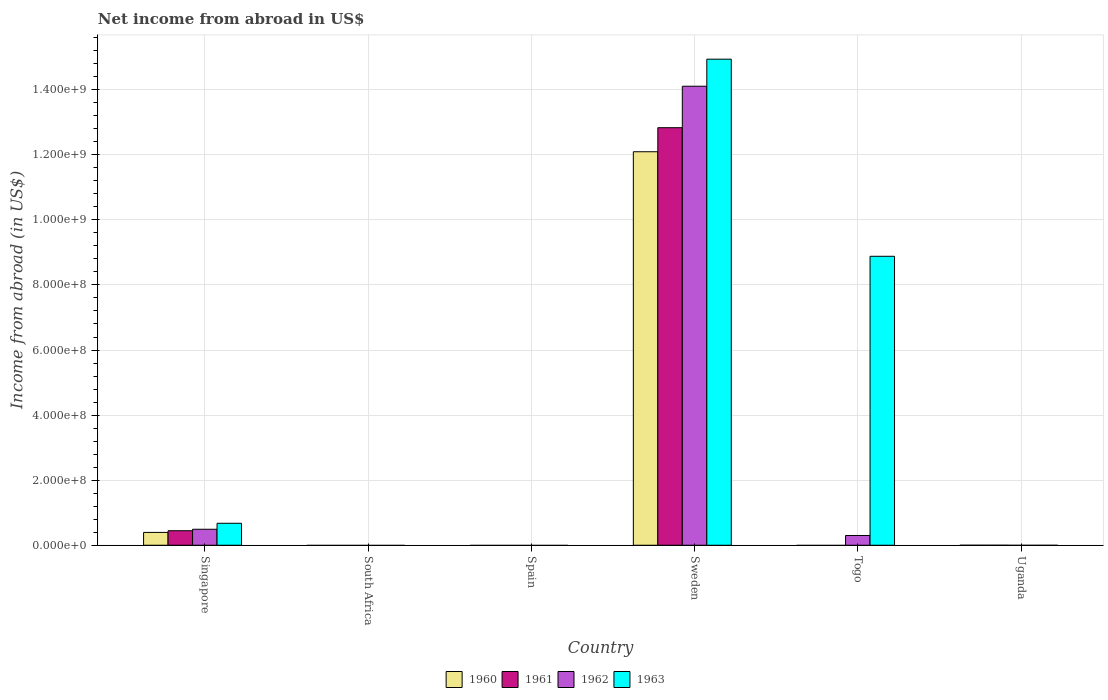Are the number of bars per tick equal to the number of legend labels?
Provide a short and direct response. No. Are the number of bars on each tick of the X-axis equal?
Give a very brief answer. No. How many bars are there on the 6th tick from the left?
Provide a succinct answer. 0. What is the label of the 5th group of bars from the left?
Provide a succinct answer. Togo. In how many cases, is the number of bars for a given country not equal to the number of legend labels?
Provide a succinct answer. 4. What is the net income from abroad in 1962 in South Africa?
Provide a short and direct response. 0. Across all countries, what is the maximum net income from abroad in 1963?
Your response must be concise. 1.49e+09. What is the total net income from abroad in 1960 in the graph?
Your response must be concise. 1.25e+09. What is the average net income from abroad in 1960 per country?
Your response must be concise. 2.08e+08. What is the difference between the net income from abroad of/in 1963 and net income from abroad of/in 1962 in Singapore?
Provide a short and direct response. 1.84e+07. In how many countries, is the net income from abroad in 1961 greater than 1160000000 US$?
Your answer should be compact. 1. What is the ratio of the net income from abroad in 1962 in Singapore to that in Togo?
Make the answer very short. 1.64. What is the difference between the highest and the second highest net income from abroad in 1962?
Offer a very short reply. 1.38e+09. What is the difference between the highest and the lowest net income from abroad in 1961?
Ensure brevity in your answer.  1.28e+09. In how many countries, is the net income from abroad in 1962 greater than the average net income from abroad in 1962 taken over all countries?
Provide a succinct answer. 1. Is it the case that in every country, the sum of the net income from abroad in 1962 and net income from abroad in 1963 is greater than the sum of net income from abroad in 1961 and net income from abroad in 1960?
Offer a very short reply. No. Is it the case that in every country, the sum of the net income from abroad in 1962 and net income from abroad in 1963 is greater than the net income from abroad in 1961?
Offer a very short reply. No. How many bars are there?
Keep it short and to the point. 10. What is the difference between two consecutive major ticks on the Y-axis?
Offer a very short reply. 2.00e+08. Where does the legend appear in the graph?
Ensure brevity in your answer.  Bottom center. How many legend labels are there?
Provide a succinct answer. 4. What is the title of the graph?
Ensure brevity in your answer.  Net income from abroad in US$. What is the label or title of the X-axis?
Provide a short and direct response. Country. What is the label or title of the Y-axis?
Make the answer very short. Income from abroad (in US$). What is the Income from abroad (in US$) in 1960 in Singapore?
Offer a very short reply. 3.94e+07. What is the Income from abroad (in US$) in 1961 in Singapore?
Provide a succinct answer. 4.46e+07. What is the Income from abroad (in US$) of 1962 in Singapore?
Offer a terse response. 4.91e+07. What is the Income from abroad (in US$) in 1963 in Singapore?
Keep it short and to the point. 6.75e+07. What is the Income from abroad (in US$) of 1961 in South Africa?
Keep it short and to the point. 0. What is the Income from abroad (in US$) in 1962 in South Africa?
Offer a terse response. 0. What is the Income from abroad (in US$) of 1961 in Spain?
Offer a very short reply. 0. What is the Income from abroad (in US$) of 1962 in Spain?
Make the answer very short. 0. What is the Income from abroad (in US$) in 1963 in Spain?
Make the answer very short. 0. What is the Income from abroad (in US$) in 1960 in Sweden?
Offer a terse response. 1.21e+09. What is the Income from abroad (in US$) of 1961 in Sweden?
Make the answer very short. 1.28e+09. What is the Income from abroad (in US$) of 1962 in Sweden?
Offer a terse response. 1.41e+09. What is the Income from abroad (in US$) in 1963 in Sweden?
Make the answer very short. 1.49e+09. What is the Income from abroad (in US$) of 1960 in Togo?
Your response must be concise. 0. What is the Income from abroad (in US$) of 1961 in Togo?
Offer a terse response. 0. What is the Income from abroad (in US$) of 1962 in Togo?
Offer a very short reply. 3.00e+07. What is the Income from abroad (in US$) of 1963 in Togo?
Give a very brief answer. 8.88e+08. What is the Income from abroad (in US$) in 1960 in Uganda?
Provide a succinct answer. 0. Across all countries, what is the maximum Income from abroad (in US$) of 1960?
Offer a very short reply. 1.21e+09. Across all countries, what is the maximum Income from abroad (in US$) of 1961?
Your response must be concise. 1.28e+09. Across all countries, what is the maximum Income from abroad (in US$) of 1962?
Make the answer very short. 1.41e+09. Across all countries, what is the maximum Income from abroad (in US$) in 1963?
Your answer should be compact. 1.49e+09. What is the total Income from abroad (in US$) in 1960 in the graph?
Make the answer very short. 1.25e+09. What is the total Income from abroad (in US$) in 1961 in the graph?
Offer a terse response. 1.33e+09. What is the total Income from abroad (in US$) in 1962 in the graph?
Provide a short and direct response. 1.49e+09. What is the total Income from abroad (in US$) in 1963 in the graph?
Your response must be concise. 2.45e+09. What is the difference between the Income from abroad (in US$) in 1960 in Singapore and that in Sweden?
Provide a succinct answer. -1.17e+09. What is the difference between the Income from abroad (in US$) in 1961 in Singapore and that in Sweden?
Your answer should be very brief. -1.24e+09. What is the difference between the Income from abroad (in US$) of 1962 in Singapore and that in Sweden?
Your answer should be compact. -1.36e+09. What is the difference between the Income from abroad (in US$) in 1963 in Singapore and that in Sweden?
Give a very brief answer. -1.43e+09. What is the difference between the Income from abroad (in US$) in 1962 in Singapore and that in Togo?
Give a very brief answer. 1.92e+07. What is the difference between the Income from abroad (in US$) in 1963 in Singapore and that in Togo?
Offer a very short reply. -8.21e+08. What is the difference between the Income from abroad (in US$) in 1962 in Sweden and that in Togo?
Give a very brief answer. 1.38e+09. What is the difference between the Income from abroad (in US$) in 1963 in Sweden and that in Togo?
Provide a succinct answer. 6.06e+08. What is the difference between the Income from abroad (in US$) of 1960 in Singapore and the Income from abroad (in US$) of 1961 in Sweden?
Ensure brevity in your answer.  -1.24e+09. What is the difference between the Income from abroad (in US$) in 1960 in Singapore and the Income from abroad (in US$) in 1962 in Sweden?
Your response must be concise. -1.37e+09. What is the difference between the Income from abroad (in US$) in 1960 in Singapore and the Income from abroad (in US$) in 1963 in Sweden?
Your answer should be very brief. -1.45e+09. What is the difference between the Income from abroad (in US$) of 1961 in Singapore and the Income from abroad (in US$) of 1962 in Sweden?
Give a very brief answer. -1.37e+09. What is the difference between the Income from abroad (in US$) in 1961 in Singapore and the Income from abroad (in US$) in 1963 in Sweden?
Your answer should be very brief. -1.45e+09. What is the difference between the Income from abroad (in US$) in 1962 in Singapore and the Income from abroad (in US$) in 1963 in Sweden?
Ensure brevity in your answer.  -1.44e+09. What is the difference between the Income from abroad (in US$) in 1960 in Singapore and the Income from abroad (in US$) in 1962 in Togo?
Your response must be concise. 9.45e+06. What is the difference between the Income from abroad (in US$) in 1960 in Singapore and the Income from abroad (in US$) in 1963 in Togo?
Provide a succinct answer. -8.49e+08. What is the difference between the Income from abroad (in US$) of 1961 in Singapore and the Income from abroad (in US$) of 1962 in Togo?
Your answer should be very brief. 1.46e+07. What is the difference between the Income from abroad (in US$) of 1961 in Singapore and the Income from abroad (in US$) of 1963 in Togo?
Make the answer very short. -8.44e+08. What is the difference between the Income from abroad (in US$) of 1962 in Singapore and the Income from abroad (in US$) of 1963 in Togo?
Your answer should be very brief. -8.39e+08. What is the difference between the Income from abroad (in US$) in 1960 in Sweden and the Income from abroad (in US$) in 1962 in Togo?
Offer a very short reply. 1.18e+09. What is the difference between the Income from abroad (in US$) of 1960 in Sweden and the Income from abroad (in US$) of 1963 in Togo?
Your answer should be very brief. 3.21e+08. What is the difference between the Income from abroad (in US$) in 1961 in Sweden and the Income from abroad (in US$) in 1962 in Togo?
Ensure brevity in your answer.  1.25e+09. What is the difference between the Income from abroad (in US$) of 1961 in Sweden and the Income from abroad (in US$) of 1963 in Togo?
Provide a short and direct response. 3.95e+08. What is the difference between the Income from abroad (in US$) in 1962 in Sweden and the Income from abroad (in US$) in 1963 in Togo?
Offer a very short reply. 5.23e+08. What is the average Income from abroad (in US$) in 1960 per country?
Offer a very short reply. 2.08e+08. What is the average Income from abroad (in US$) in 1961 per country?
Your answer should be compact. 2.21e+08. What is the average Income from abroad (in US$) in 1962 per country?
Your answer should be compact. 2.48e+08. What is the average Income from abroad (in US$) in 1963 per country?
Provide a short and direct response. 4.08e+08. What is the difference between the Income from abroad (in US$) in 1960 and Income from abroad (in US$) in 1961 in Singapore?
Your response must be concise. -5.20e+06. What is the difference between the Income from abroad (in US$) of 1960 and Income from abroad (in US$) of 1962 in Singapore?
Your answer should be compact. -9.70e+06. What is the difference between the Income from abroad (in US$) in 1960 and Income from abroad (in US$) in 1963 in Singapore?
Provide a succinct answer. -2.81e+07. What is the difference between the Income from abroad (in US$) in 1961 and Income from abroad (in US$) in 1962 in Singapore?
Give a very brief answer. -4.50e+06. What is the difference between the Income from abroad (in US$) of 1961 and Income from abroad (in US$) of 1963 in Singapore?
Your answer should be compact. -2.29e+07. What is the difference between the Income from abroad (in US$) in 1962 and Income from abroad (in US$) in 1963 in Singapore?
Your answer should be compact. -1.84e+07. What is the difference between the Income from abroad (in US$) of 1960 and Income from abroad (in US$) of 1961 in Sweden?
Give a very brief answer. -7.39e+07. What is the difference between the Income from abroad (in US$) of 1960 and Income from abroad (in US$) of 1962 in Sweden?
Give a very brief answer. -2.01e+08. What is the difference between the Income from abroad (in US$) of 1960 and Income from abroad (in US$) of 1963 in Sweden?
Keep it short and to the point. -2.84e+08. What is the difference between the Income from abroad (in US$) in 1961 and Income from abroad (in US$) in 1962 in Sweden?
Give a very brief answer. -1.27e+08. What is the difference between the Income from abroad (in US$) in 1961 and Income from abroad (in US$) in 1963 in Sweden?
Your answer should be compact. -2.11e+08. What is the difference between the Income from abroad (in US$) of 1962 and Income from abroad (in US$) of 1963 in Sweden?
Make the answer very short. -8.31e+07. What is the difference between the Income from abroad (in US$) of 1962 and Income from abroad (in US$) of 1963 in Togo?
Give a very brief answer. -8.58e+08. What is the ratio of the Income from abroad (in US$) in 1960 in Singapore to that in Sweden?
Offer a very short reply. 0.03. What is the ratio of the Income from abroad (in US$) in 1961 in Singapore to that in Sweden?
Keep it short and to the point. 0.03. What is the ratio of the Income from abroad (in US$) in 1962 in Singapore to that in Sweden?
Keep it short and to the point. 0.03. What is the ratio of the Income from abroad (in US$) in 1963 in Singapore to that in Sweden?
Offer a terse response. 0.05. What is the ratio of the Income from abroad (in US$) of 1962 in Singapore to that in Togo?
Offer a terse response. 1.64. What is the ratio of the Income from abroad (in US$) of 1963 in Singapore to that in Togo?
Give a very brief answer. 0.08. What is the ratio of the Income from abroad (in US$) in 1962 in Sweden to that in Togo?
Keep it short and to the point. 47.1. What is the ratio of the Income from abroad (in US$) of 1963 in Sweden to that in Togo?
Provide a succinct answer. 1.68. What is the difference between the highest and the second highest Income from abroad (in US$) of 1962?
Keep it short and to the point. 1.36e+09. What is the difference between the highest and the second highest Income from abroad (in US$) in 1963?
Keep it short and to the point. 6.06e+08. What is the difference between the highest and the lowest Income from abroad (in US$) in 1960?
Provide a short and direct response. 1.21e+09. What is the difference between the highest and the lowest Income from abroad (in US$) in 1961?
Offer a terse response. 1.28e+09. What is the difference between the highest and the lowest Income from abroad (in US$) of 1962?
Offer a terse response. 1.41e+09. What is the difference between the highest and the lowest Income from abroad (in US$) in 1963?
Provide a short and direct response. 1.49e+09. 